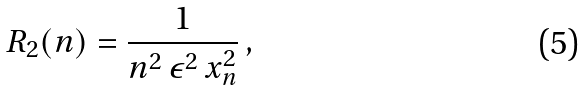Convert formula to latex. <formula><loc_0><loc_0><loc_500><loc_500>R _ { 2 } ( n ) = \frac { 1 } { n ^ { 2 } \, \epsilon ^ { 2 } \, x _ { n } ^ { 2 } } \, ,</formula> 